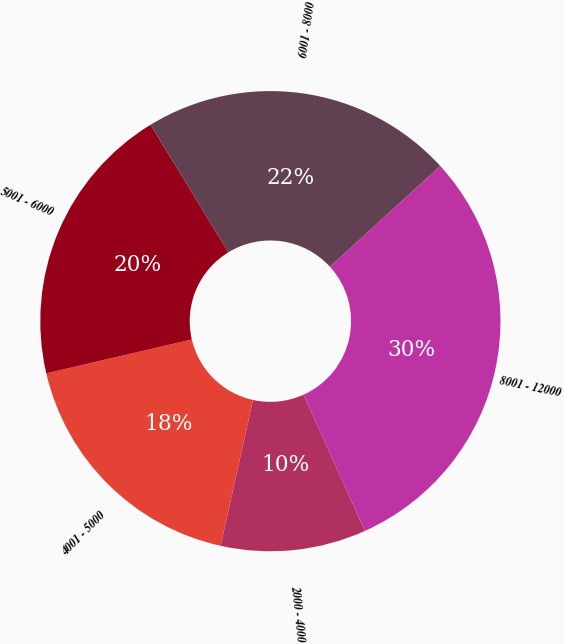Convert chart to OTSL. <chart><loc_0><loc_0><loc_500><loc_500><pie_chart><fcel>2000 - 4000<fcel>4001 - 5000<fcel>5001 - 6000<fcel>6001 - 8000<fcel>8001 - 12000<nl><fcel>10.21%<fcel>17.89%<fcel>19.92%<fcel>21.94%<fcel>30.04%<nl></chart> 